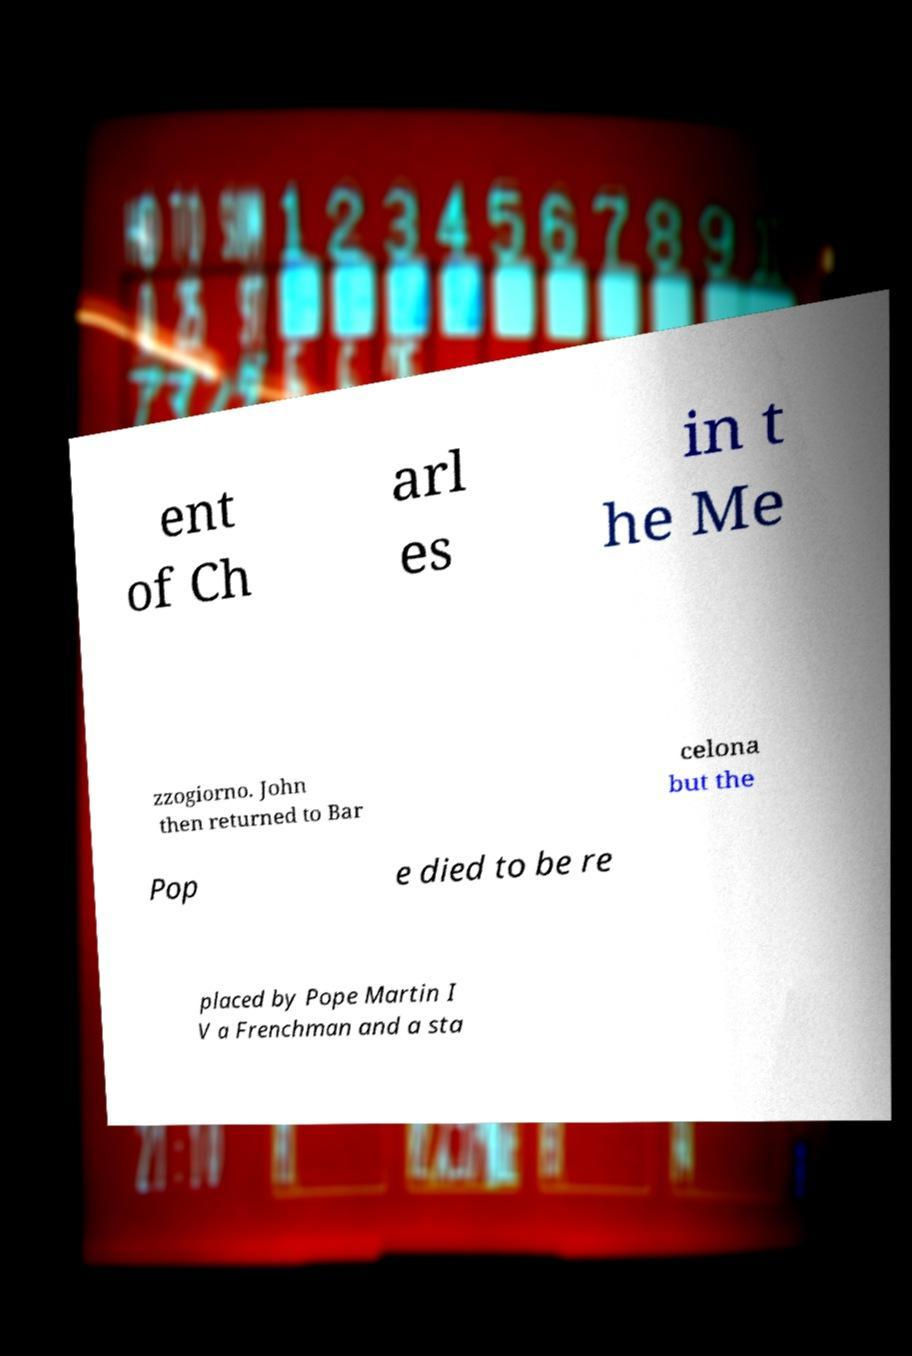Could you assist in decoding the text presented in this image and type it out clearly? ent of Ch arl es in t he Me zzogiorno. John then returned to Bar celona but the Pop e died to be re placed by Pope Martin I V a Frenchman and a sta 